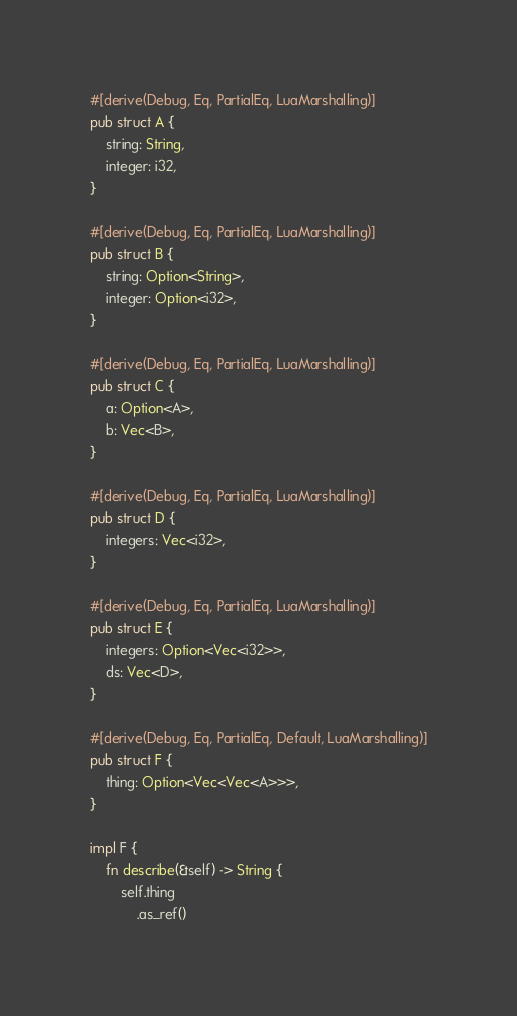<code> <loc_0><loc_0><loc_500><loc_500><_Rust_>#[derive(Debug, Eq, PartialEq, LuaMarshalling)]
pub struct A {
    string: String,
    integer: i32,
}

#[derive(Debug, Eq, PartialEq, LuaMarshalling)]
pub struct B {
    string: Option<String>,
    integer: Option<i32>,
}

#[derive(Debug, Eq, PartialEq, LuaMarshalling)]
pub struct C {
    a: Option<A>,
    b: Vec<B>,
}

#[derive(Debug, Eq, PartialEq, LuaMarshalling)]
pub struct D {
    integers: Vec<i32>,
}

#[derive(Debug, Eq, PartialEq, LuaMarshalling)]
pub struct E {
    integers: Option<Vec<i32>>,
    ds: Vec<D>,
}

#[derive(Debug, Eq, PartialEq, Default, LuaMarshalling)]
pub struct F {
    thing: Option<Vec<Vec<A>>>,
}

impl F {
    fn describe(&self) -> String {
        self.thing
            .as_ref()</code> 